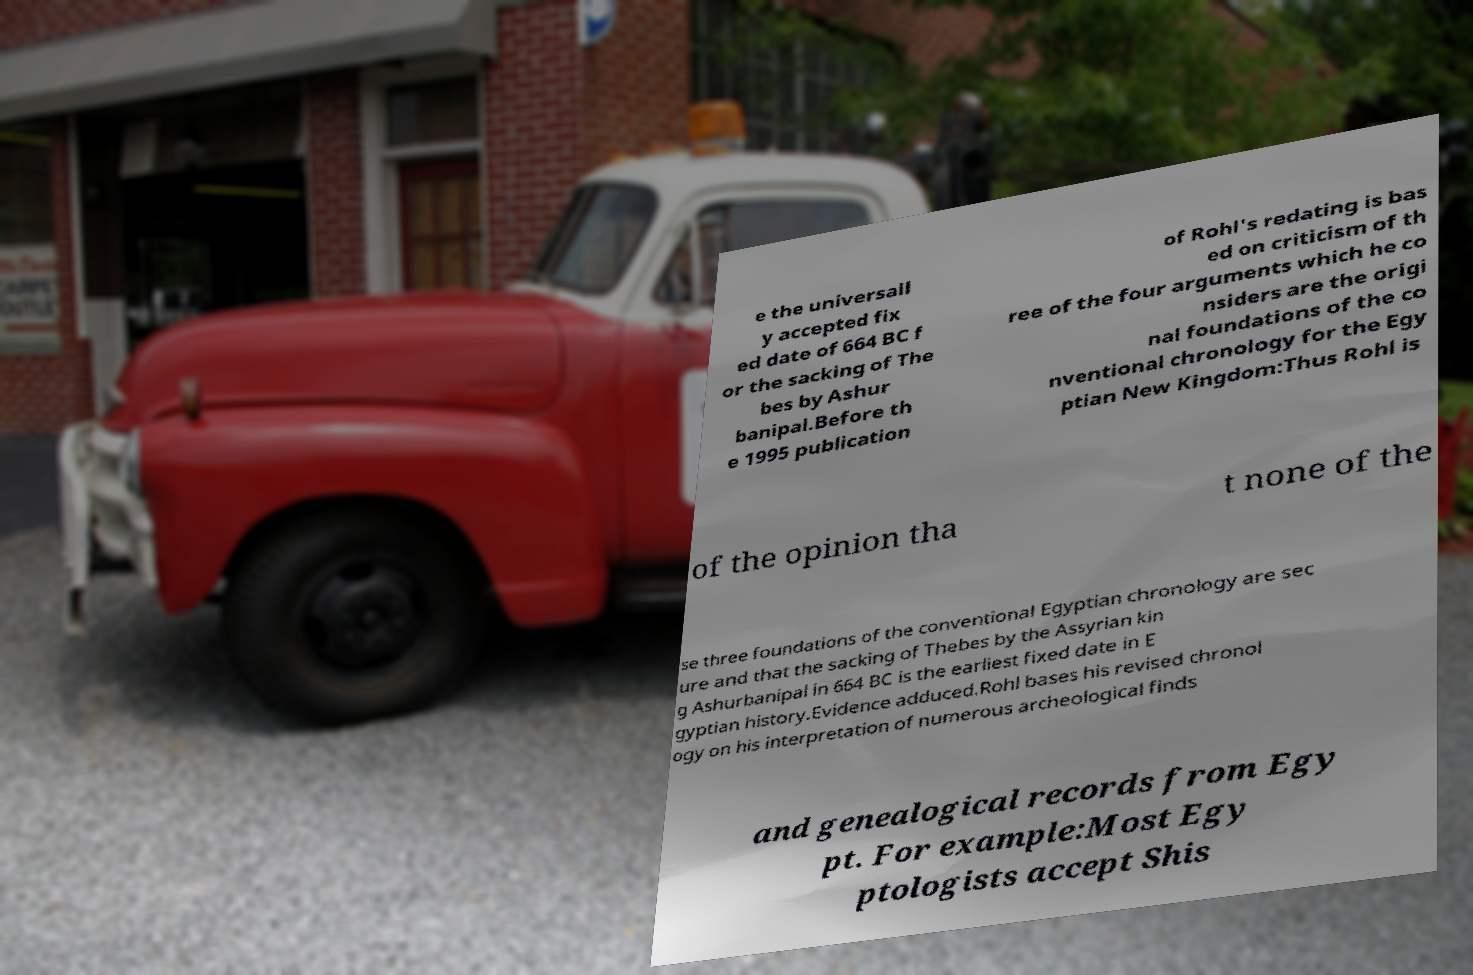Please read and relay the text visible in this image. What does it say? e the universall y accepted fix ed date of 664 BC f or the sacking of The bes by Ashur banipal.Before th e 1995 publication of Rohl's redating is bas ed on criticism of th ree of the four arguments which he co nsiders are the origi nal foundations of the co nventional chronology for the Egy ptian New Kingdom:Thus Rohl is of the opinion tha t none of the se three foundations of the conventional Egyptian chronology are sec ure and that the sacking of Thebes by the Assyrian kin g Ashurbanipal in 664 BC is the earliest fixed date in E gyptian history.Evidence adduced.Rohl bases his revised chronol ogy on his interpretation of numerous archeological finds and genealogical records from Egy pt. For example:Most Egy ptologists accept Shis 